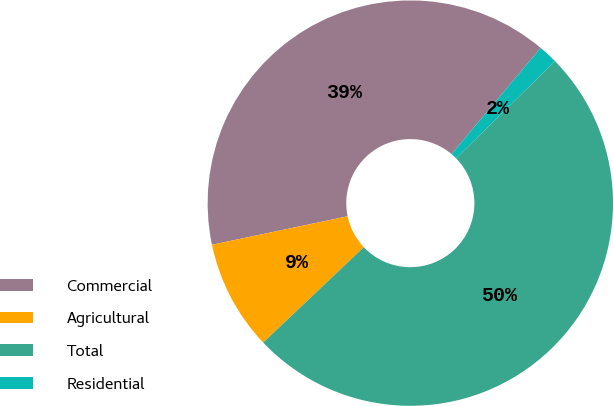Convert chart. <chart><loc_0><loc_0><loc_500><loc_500><pie_chart><fcel>Commercial<fcel>Agricultural<fcel>Total<fcel>Residential<nl><fcel>39.41%<fcel>8.78%<fcel>50.27%<fcel>1.54%<nl></chart> 